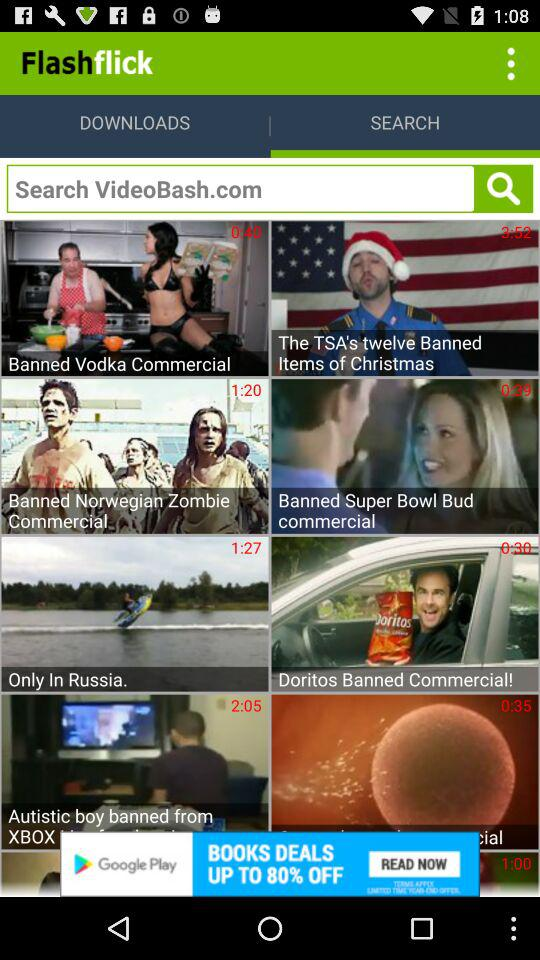Which video has a duration of 1 minute 20 seconds? The video that has a duration of 1 minute 20 seconds is "Banned Norwegian Zombie Commercial". 